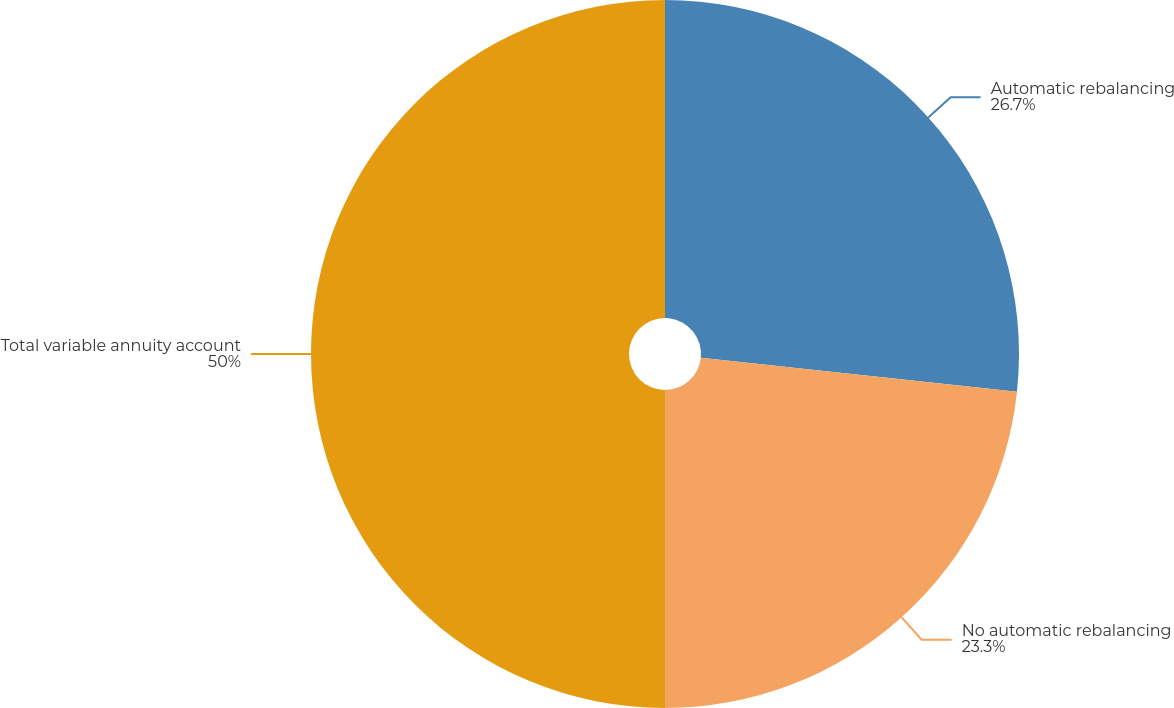<chart> <loc_0><loc_0><loc_500><loc_500><pie_chart><fcel>Automatic rebalancing<fcel>No automatic rebalancing<fcel>Total variable annuity account<nl><fcel>26.7%<fcel>23.3%<fcel>50.0%<nl></chart> 